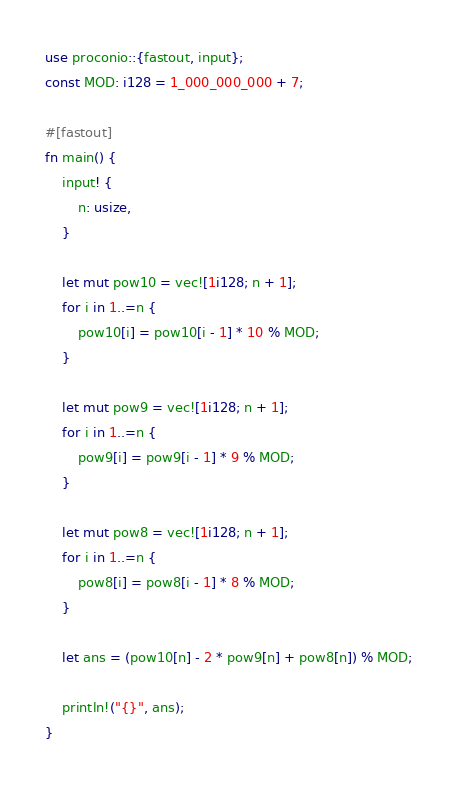<code> <loc_0><loc_0><loc_500><loc_500><_Rust_>use proconio::{fastout, input};
const MOD: i128 = 1_000_000_000 + 7;

#[fastout]
fn main() {
    input! {
        n: usize,
    }

    let mut pow10 = vec![1i128; n + 1];
    for i in 1..=n {
        pow10[i] = pow10[i - 1] * 10 % MOD;
    }

    let mut pow9 = vec![1i128; n + 1];
    for i in 1..=n {
        pow9[i] = pow9[i - 1] * 9 % MOD;
    }

    let mut pow8 = vec![1i128; n + 1];
    for i in 1..=n {
        pow8[i] = pow8[i - 1] * 8 % MOD;
    }

    let ans = (pow10[n] - 2 * pow9[n] + pow8[n]) % MOD;

    println!("{}", ans);
}
</code> 